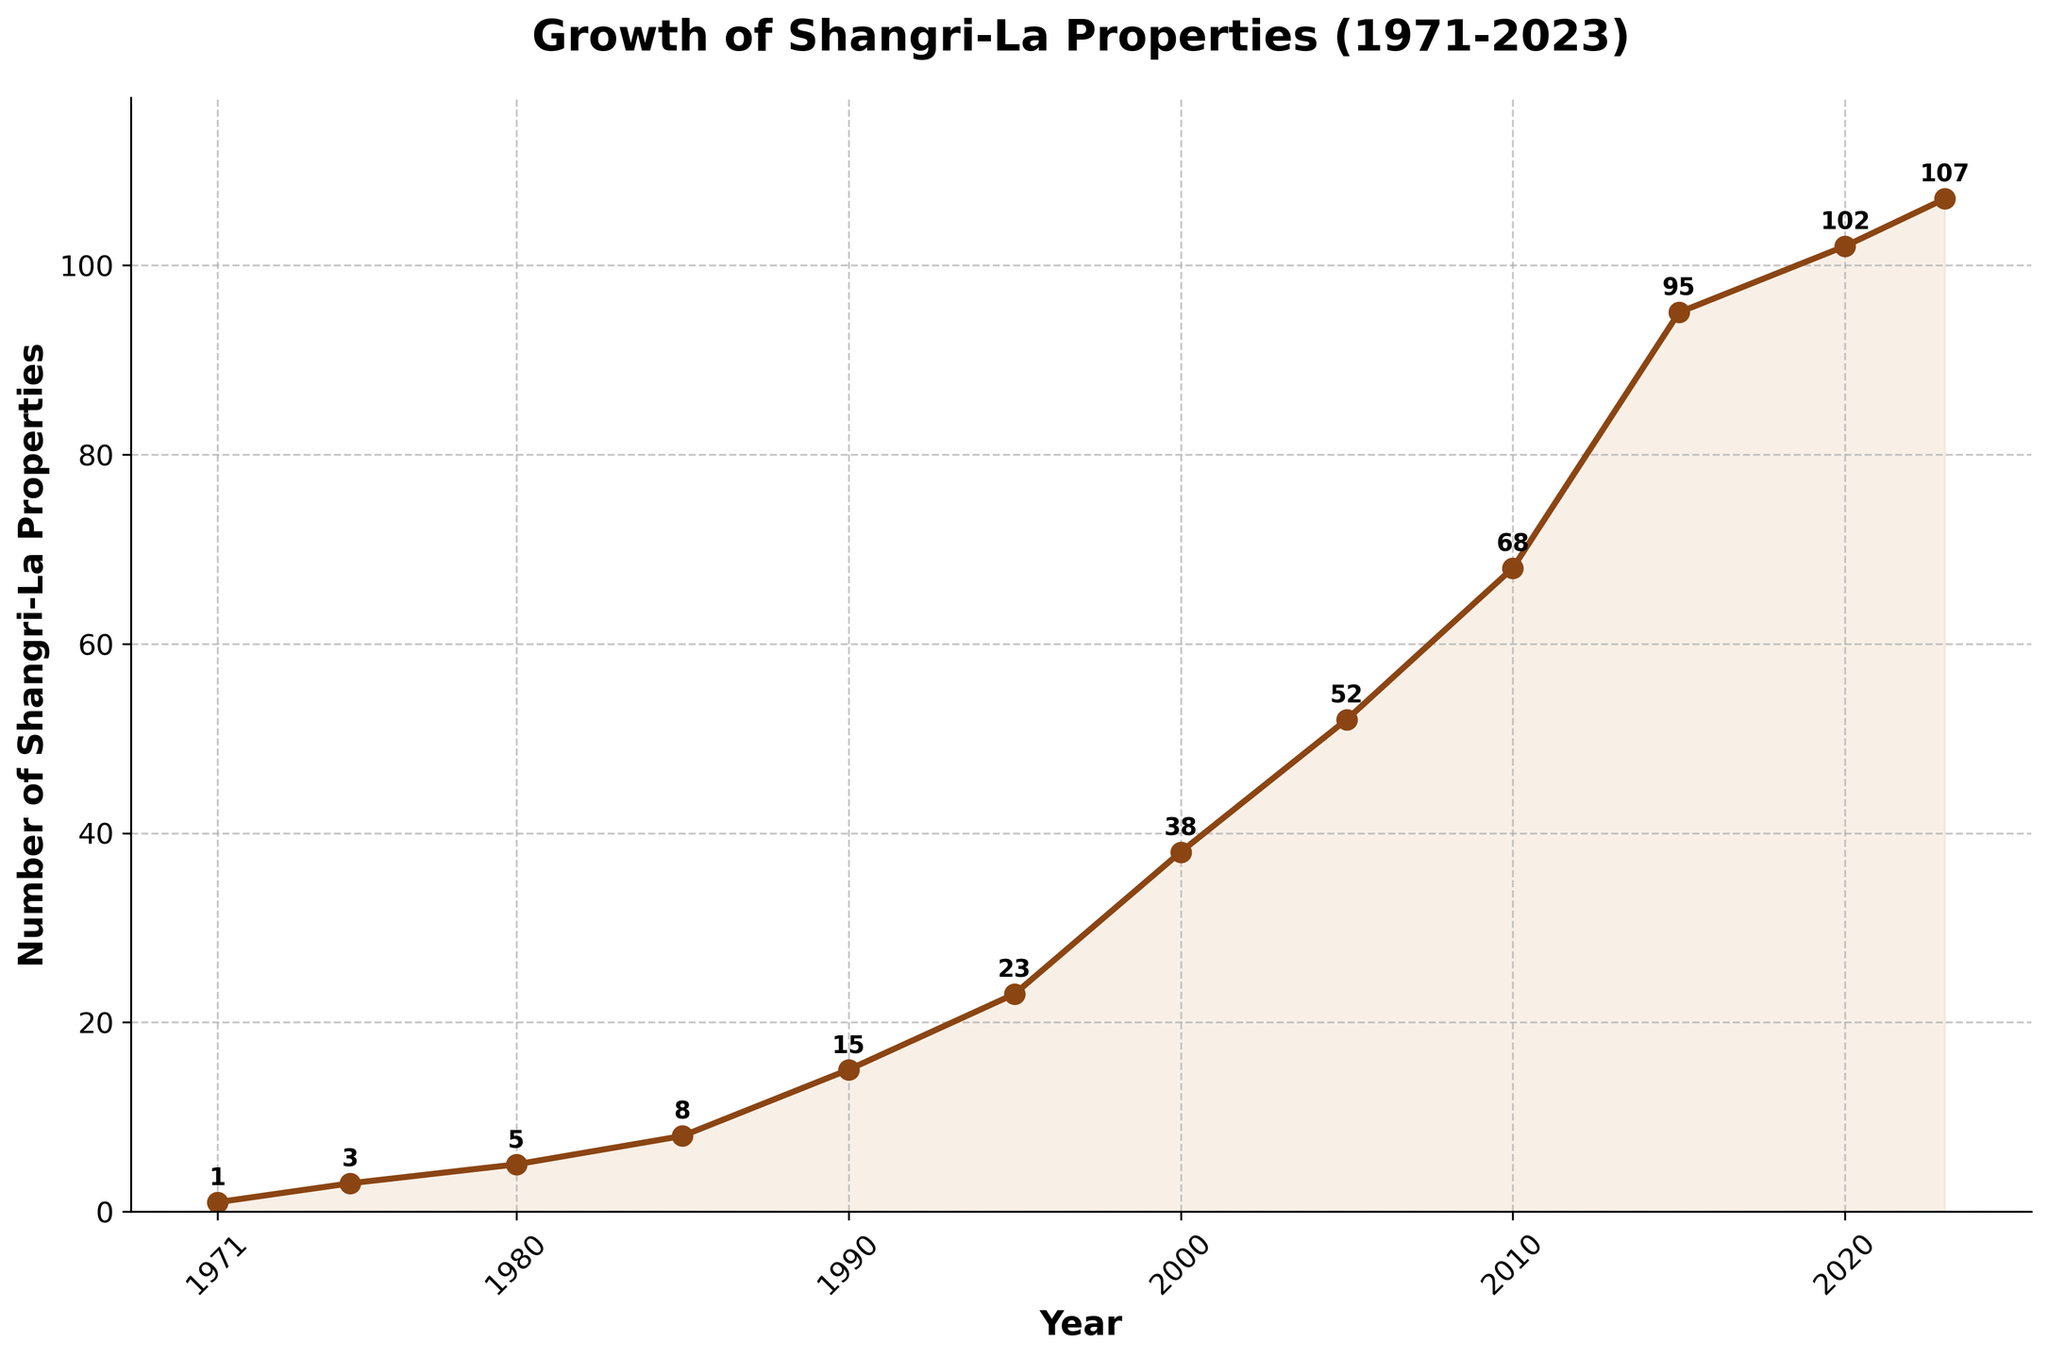What was the total number of Shangri-La properties in 1995 and 2005 combined? From the chart, the number of properties in 1995 is 23 and in 2005 is 52. Summing up these numbers, we get 23 + 52 = 75.
Answer: 75 Which year had the highest increase in the number of properties compared to the previous year? By examining the differences between consecutive years, the largest increase seems to be between 1990 (15 properties) and 1995 (23 properties). The increase is 23 - 15 = 8 properties.
Answer: 1995 How many properties were added between 2010 and 2020? In 2010, there were 68 properties, and in 2020, there were 102 properties. The difference is 102 - 68 = 34 properties.
Answer: 34 By how much did the number of Shangri-La properties increase from 1971 to 2023? From the chart, in 1971 there was 1 property and in 2023 there are 107 properties. The increase can be calculated as 107 - 1 = 106 properties.
Answer: 106 Which decade saw the largest growth in the number of Shangri-La properties? To find the decade with the largest growth, we calculate the difference for each decade: 
- 1971-1980: 5 - 1 = 4
- 1980-1990: 15 - 5 = 10
- 1990-2000: 38 - 15 = 23
- 2000-2010: 68 - 38 = 30
- 2010-2020: 102 - 68 = 34
The largest growth occurred between 2010 and 2020 with an increase of 34 properties.
Answer: 2010-2020 How does the growth between 1985 and 1995 compare to the growth between 2005 and 2015? From the chart, the number of properties in 1985 is 8 and in 1995 is 23. The growth is 23 - 8 = 15 properties. The growth from 2005 to 2015 is 95 - 52 = 43 properties. Comparing these, 43 is greater than 15.
Answer: 2005-2015 What is the average number of properties added per year between 1990 and 2000? In 1990, there were 15 properties and in 2000, there were 38 properties. The difference is 38 - 15 = 23 properties over 10 years. The average per year is 23 / 10 = 2.3 properties/year.
Answer: 2.3 properties/year What are the visual characteristics of the line representing the number of properties over time? The line in the chart is brown with circular markers at the data points, increasing steadily with time. The area under the line is shaded in a light brown color, creating a visually pleasing representation of growth.
Answer: Brown line with markers and light brown shaded area Does the number of Shangri-La properties ever decrease between any two years shown on the chart? Looking at the trend in the chart, the number of properties consistently increases every year; it never decreases.
Answer: No 